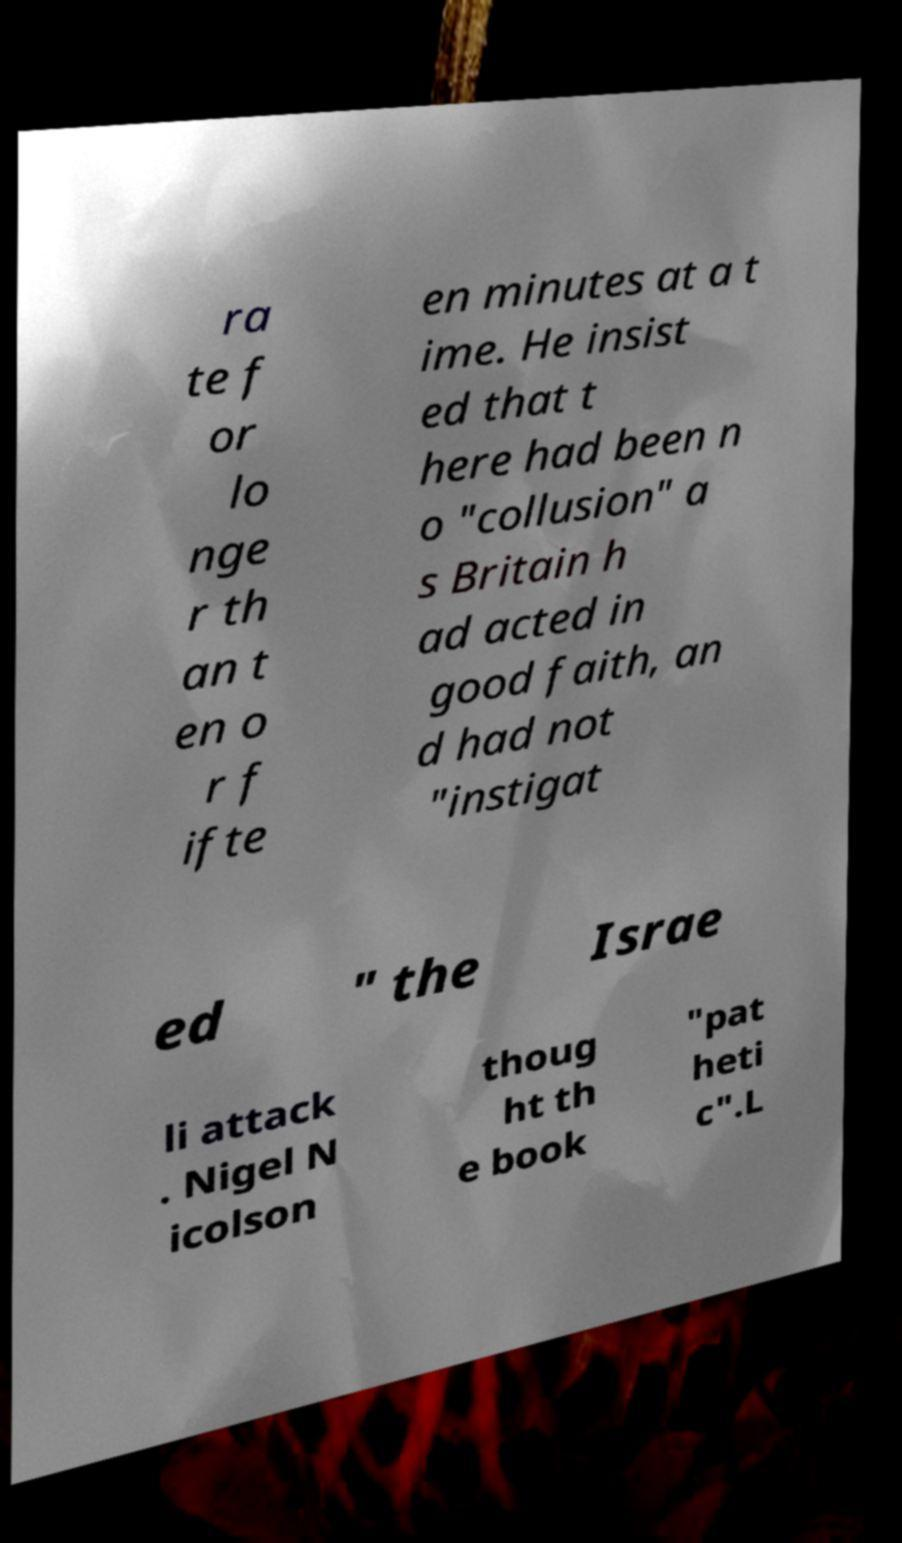What messages or text are displayed in this image? I need them in a readable, typed format. ra te f or lo nge r th an t en o r f ifte en minutes at a t ime. He insist ed that t here had been n o "collusion" a s Britain h ad acted in good faith, an d had not "instigat ed " the Israe li attack . Nigel N icolson thoug ht th e book "pat heti c".L 